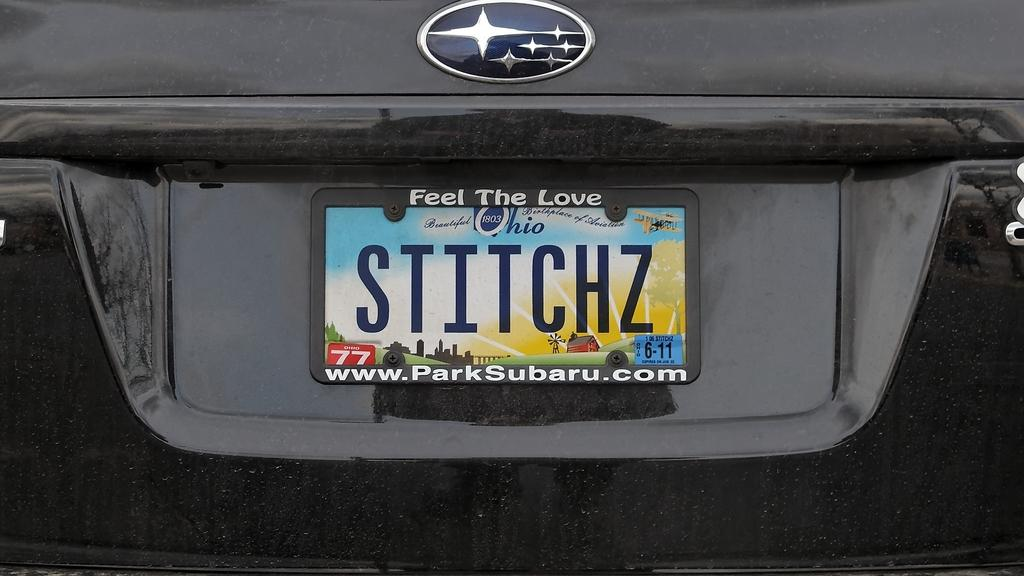<image>
Create a compact narrative representing the image presented. A black Subaru with an Ohio license plate. 